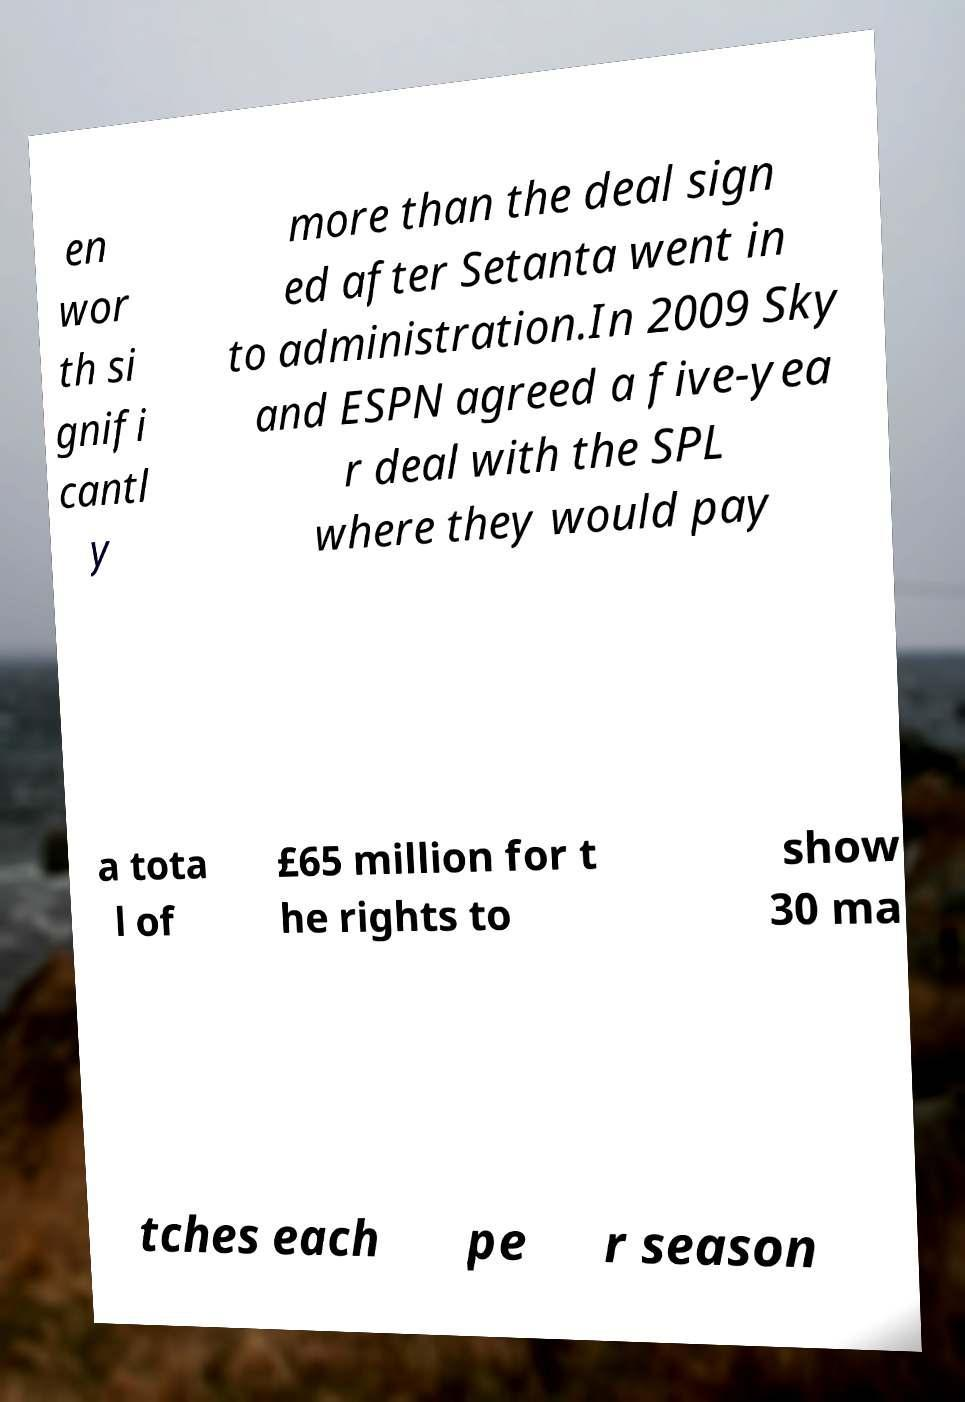For documentation purposes, I need the text within this image transcribed. Could you provide that? en wor th si gnifi cantl y more than the deal sign ed after Setanta went in to administration.In 2009 Sky and ESPN agreed a five-yea r deal with the SPL where they would pay a tota l of £65 million for t he rights to show 30 ma tches each pe r season 